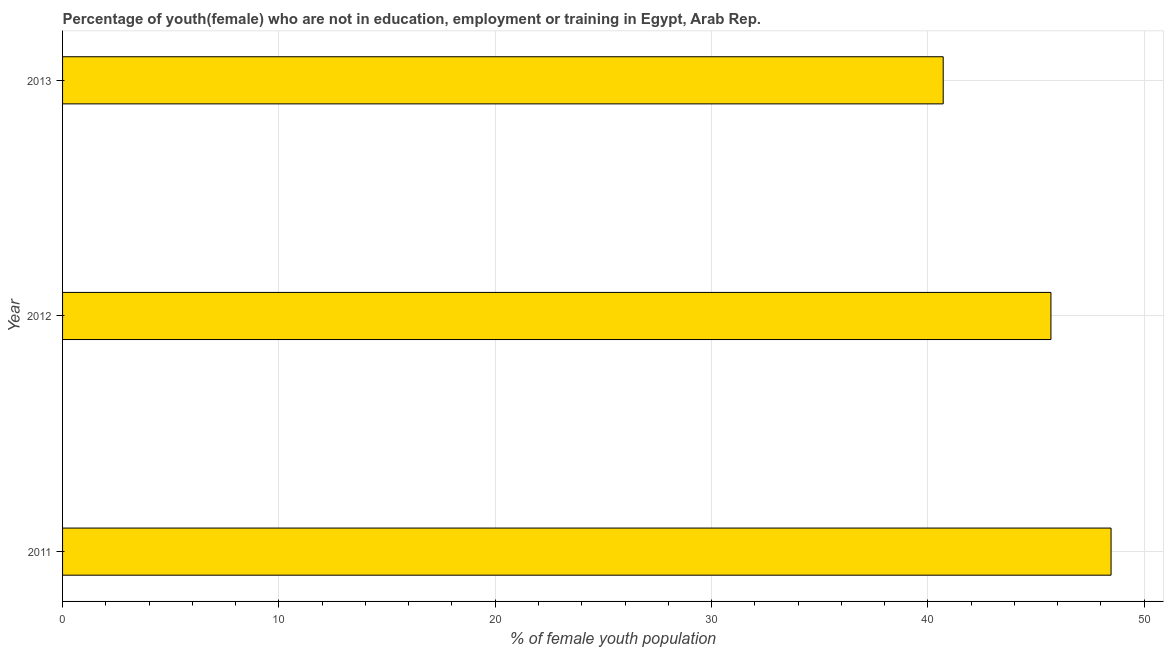Does the graph contain grids?
Your answer should be compact. Yes. What is the title of the graph?
Give a very brief answer. Percentage of youth(female) who are not in education, employment or training in Egypt, Arab Rep. What is the label or title of the X-axis?
Offer a terse response. % of female youth population. What is the label or title of the Y-axis?
Keep it short and to the point. Year. What is the unemployed female youth population in 2012?
Make the answer very short. 45.69. Across all years, what is the maximum unemployed female youth population?
Your response must be concise. 48.47. Across all years, what is the minimum unemployed female youth population?
Keep it short and to the point. 40.71. In which year was the unemployed female youth population maximum?
Your answer should be very brief. 2011. In which year was the unemployed female youth population minimum?
Give a very brief answer. 2013. What is the sum of the unemployed female youth population?
Give a very brief answer. 134.87. What is the difference between the unemployed female youth population in 2012 and 2013?
Provide a succinct answer. 4.98. What is the average unemployed female youth population per year?
Offer a terse response. 44.96. What is the median unemployed female youth population?
Provide a succinct answer. 45.69. In how many years, is the unemployed female youth population greater than 32 %?
Your response must be concise. 3. What is the ratio of the unemployed female youth population in 2011 to that in 2012?
Offer a very short reply. 1.06. Is the difference between the unemployed female youth population in 2011 and 2013 greater than the difference between any two years?
Make the answer very short. Yes. What is the difference between the highest and the second highest unemployed female youth population?
Ensure brevity in your answer.  2.78. Is the sum of the unemployed female youth population in 2012 and 2013 greater than the maximum unemployed female youth population across all years?
Offer a terse response. Yes. What is the difference between the highest and the lowest unemployed female youth population?
Give a very brief answer. 7.76. How many bars are there?
Keep it short and to the point. 3. Are all the bars in the graph horizontal?
Give a very brief answer. Yes. What is the % of female youth population of 2011?
Ensure brevity in your answer.  48.47. What is the % of female youth population in 2012?
Your answer should be very brief. 45.69. What is the % of female youth population in 2013?
Ensure brevity in your answer.  40.71. What is the difference between the % of female youth population in 2011 and 2012?
Make the answer very short. 2.78. What is the difference between the % of female youth population in 2011 and 2013?
Provide a succinct answer. 7.76. What is the difference between the % of female youth population in 2012 and 2013?
Make the answer very short. 4.98. What is the ratio of the % of female youth population in 2011 to that in 2012?
Provide a short and direct response. 1.06. What is the ratio of the % of female youth population in 2011 to that in 2013?
Your answer should be very brief. 1.19. What is the ratio of the % of female youth population in 2012 to that in 2013?
Your response must be concise. 1.12. 